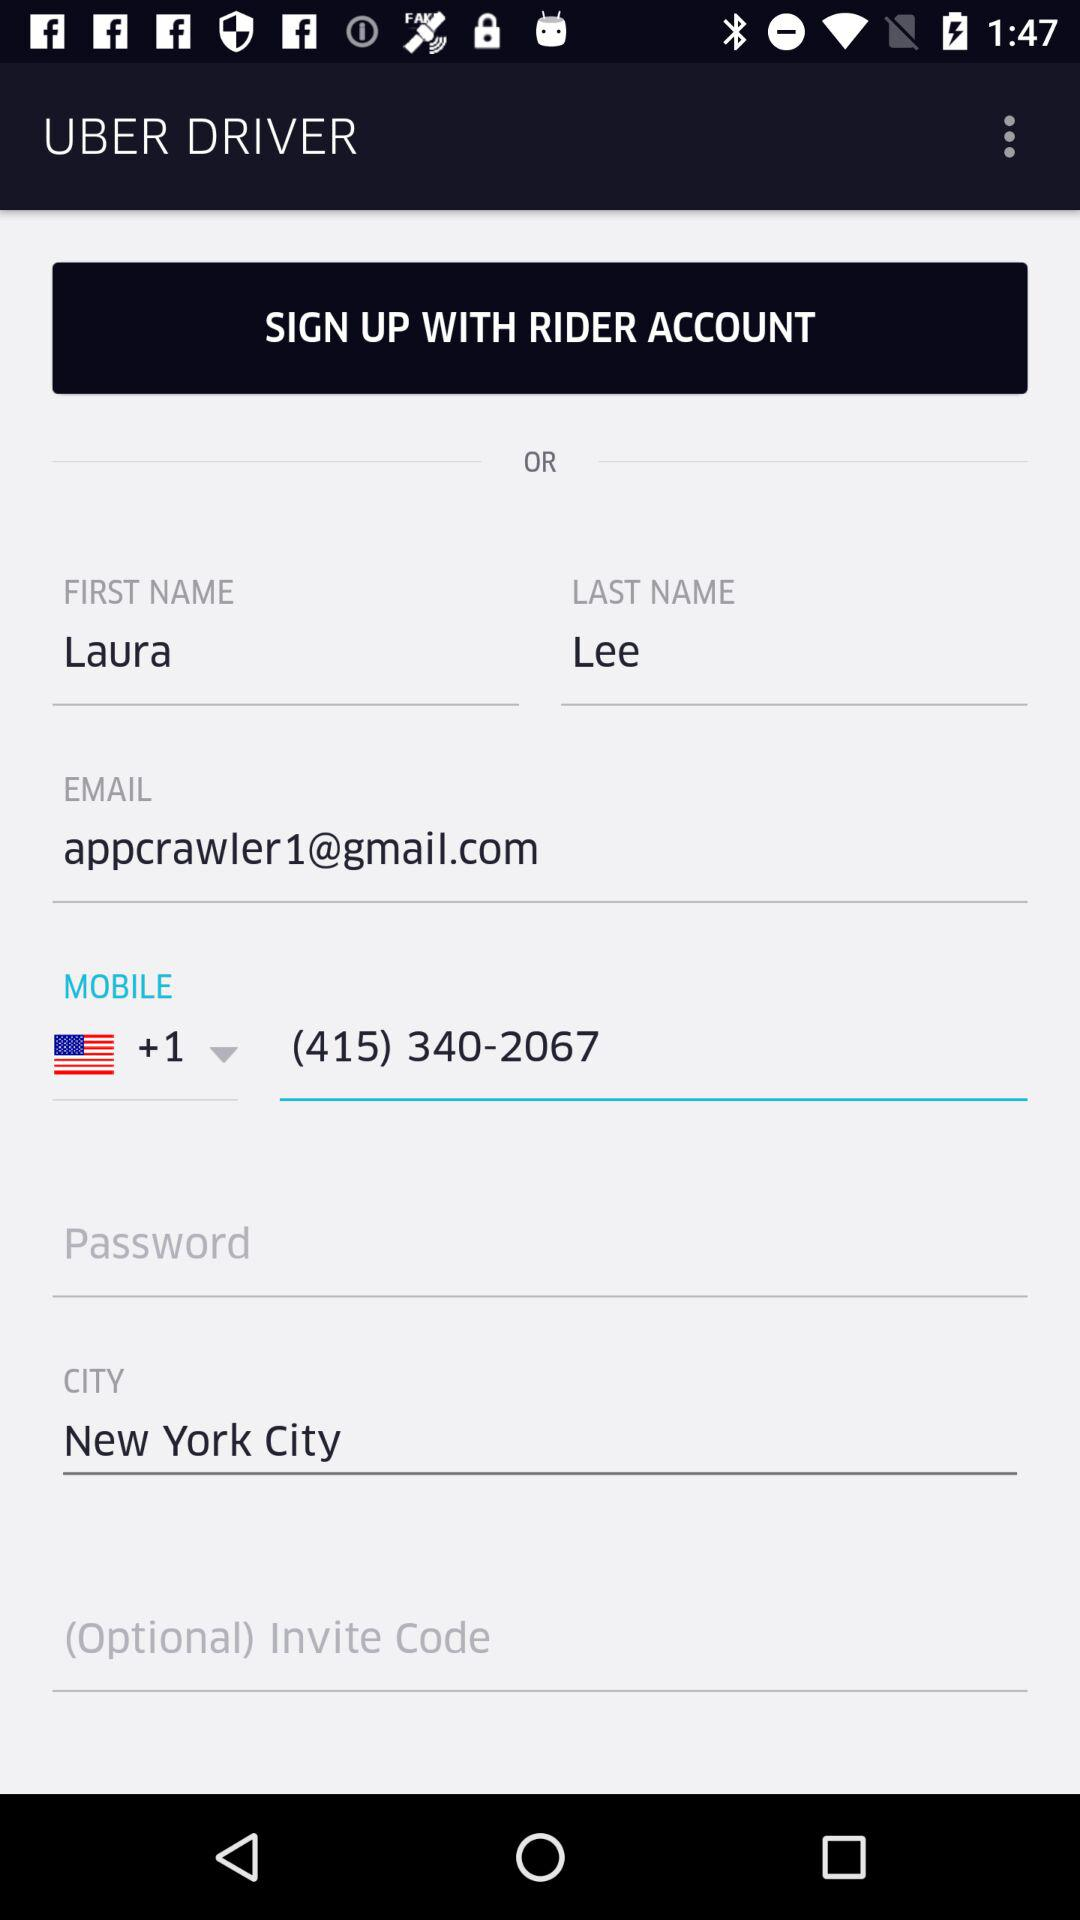What is the last name? The last name is Lee. 